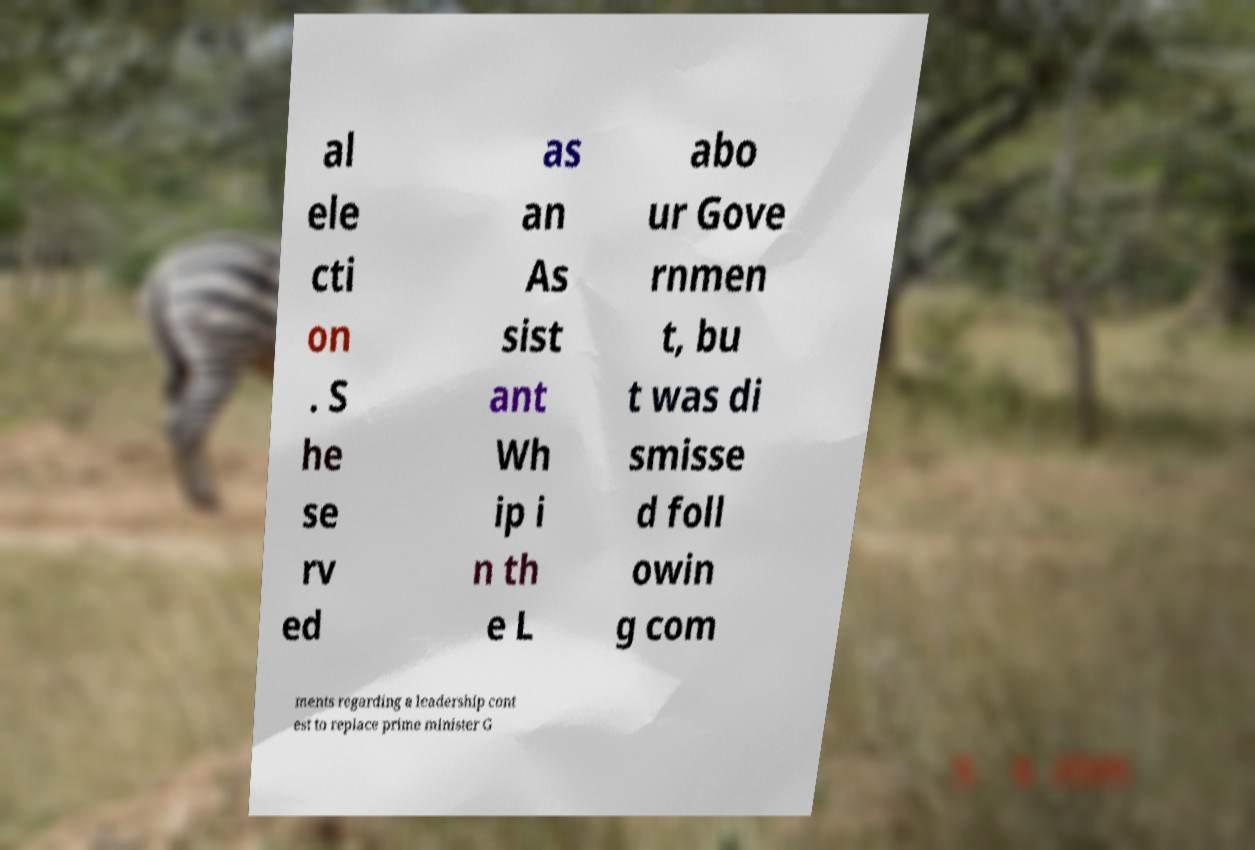What messages or text are displayed in this image? I need them in a readable, typed format. al ele cti on . S he se rv ed as an As sist ant Wh ip i n th e L abo ur Gove rnmen t, bu t was di smisse d foll owin g com ments regarding a leadership cont est to replace prime minister G 